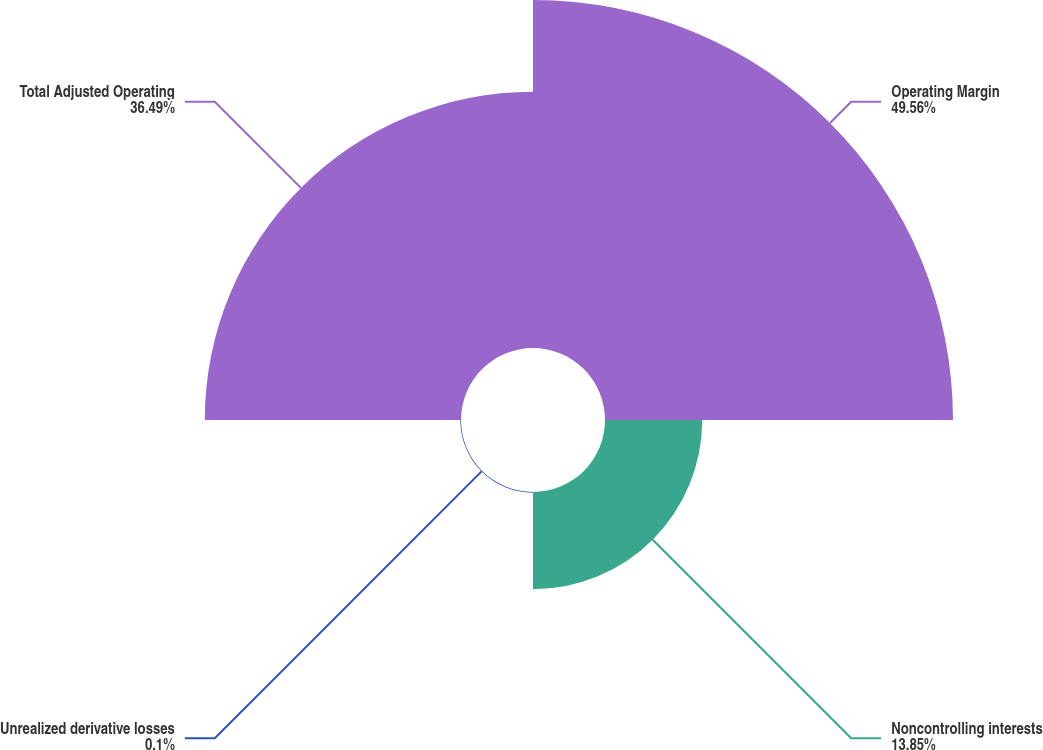<chart> <loc_0><loc_0><loc_500><loc_500><pie_chart><fcel>Operating Margin<fcel>Noncontrolling interests<fcel>Unrealized derivative losses<fcel>Total Adjusted Operating<nl><fcel>49.56%<fcel>13.85%<fcel>0.1%<fcel>36.49%<nl></chart> 